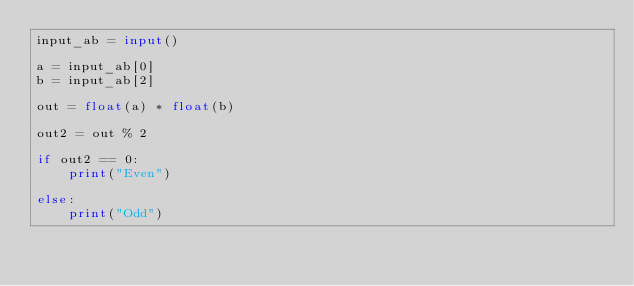<code> <loc_0><loc_0><loc_500><loc_500><_Python_>input_ab = input()

a = input_ab[0]
b = input_ab[2]

out = float(a) * float(b)

out2 = out % 2

if out2 == 0:
    print("Even")

else:
    print("Odd")</code> 